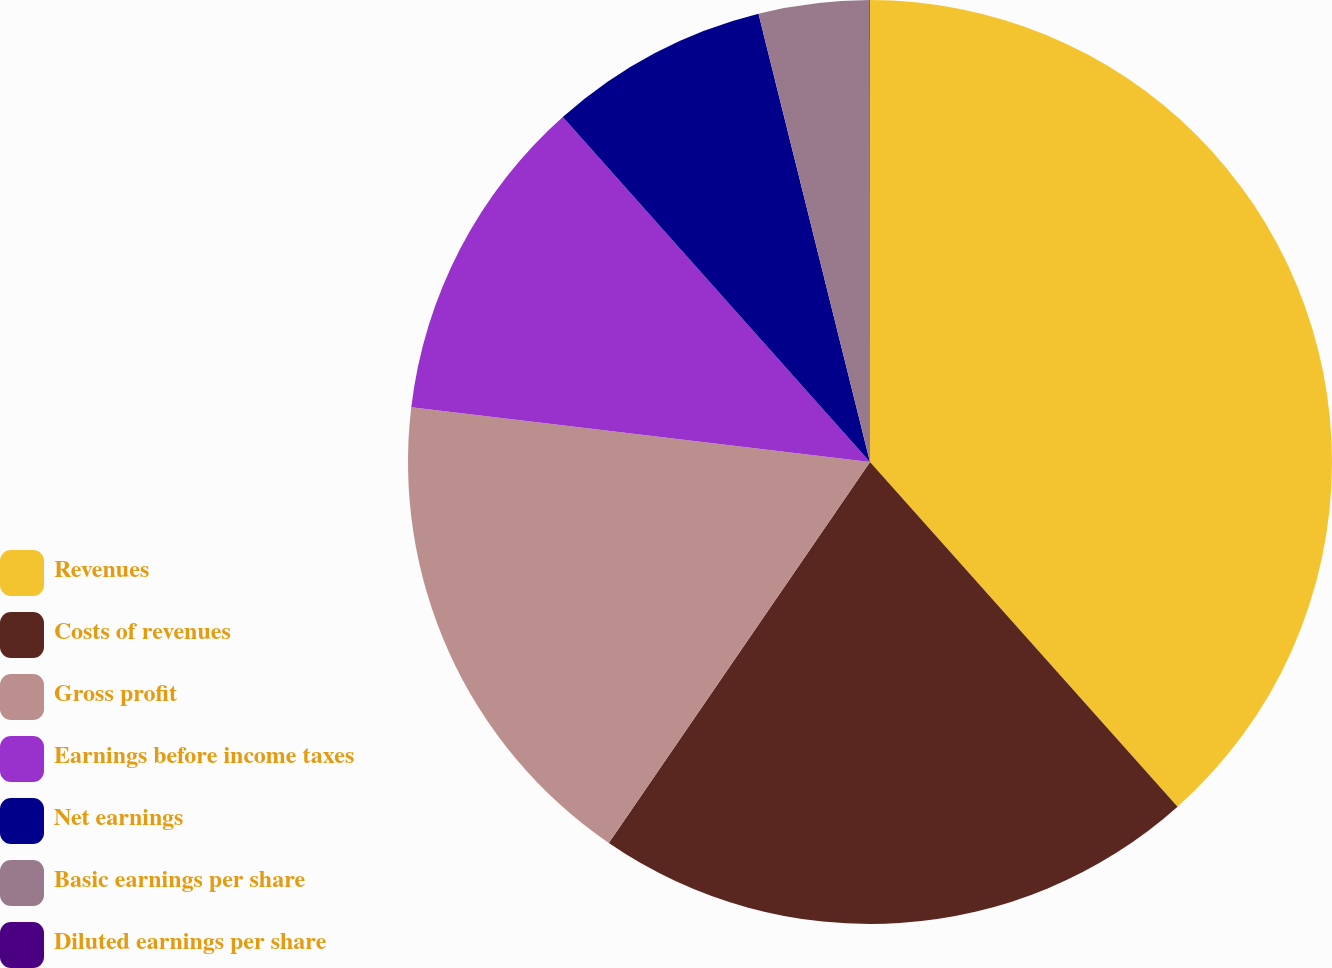Convert chart to OTSL. <chart><loc_0><loc_0><loc_500><loc_500><pie_chart><fcel>Revenues<fcel>Costs of revenues<fcel>Gross profit<fcel>Earnings before income taxes<fcel>Net earnings<fcel>Basic earnings per share<fcel>Diluted earnings per share<nl><fcel>38.41%<fcel>21.16%<fcel>17.33%<fcel>11.53%<fcel>7.7%<fcel>3.86%<fcel>0.02%<nl></chart> 